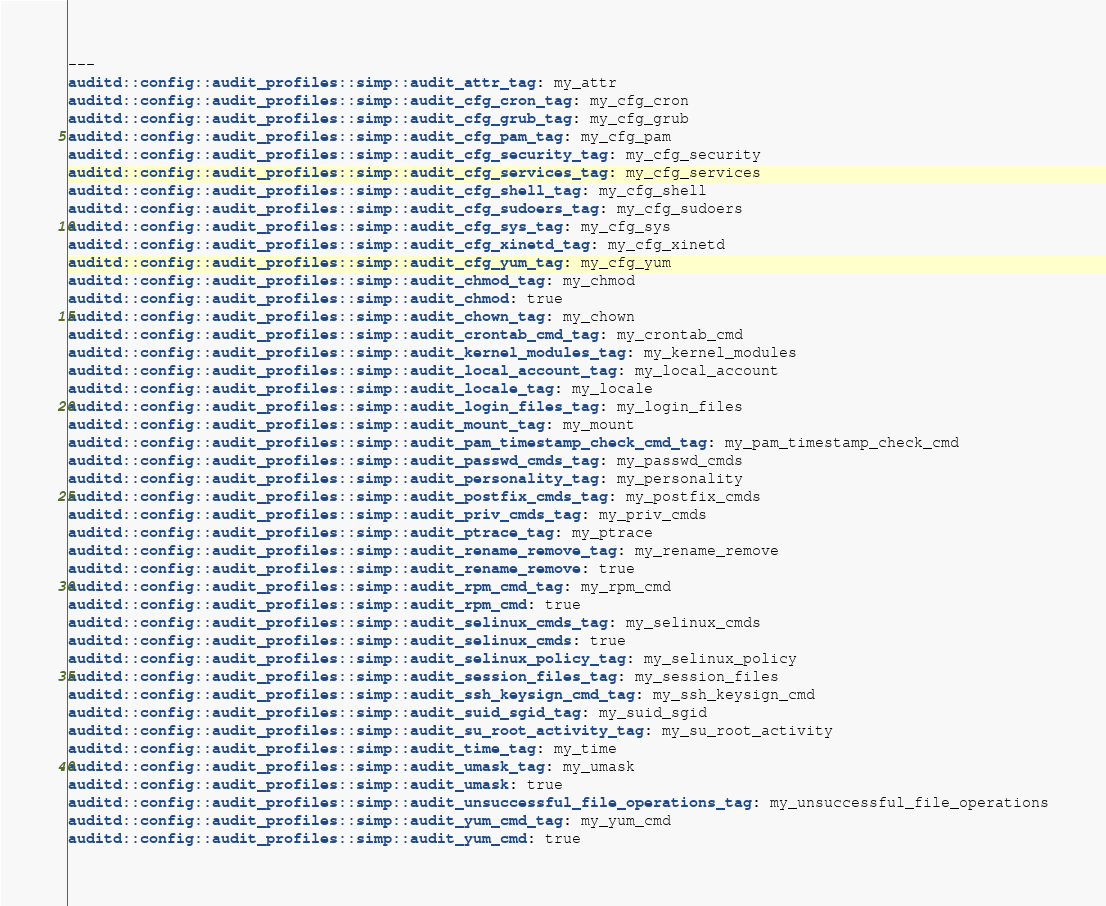Convert code to text. <code><loc_0><loc_0><loc_500><loc_500><_YAML_>---
auditd::config::audit_profiles::simp::audit_attr_tag: my_attr
auditd::config::audit_profiles::simp::audit_cfg_cron_tag: my_cfg_cron
auditd::config::audit_profiles::simp::audit_cfg_grub_tag: my_cfg_grub
auditd::config::audit_profiles::simp::audit_cfg_pam_tag: my_cfg_pam
auditd::config::audit_profiles::simp::audit_cfg_security_tag: my_cfg_security
auditd::config::audit_profiles::simp::audit_cfg_services_tag: my_cfg_services
auditd::config::audit_profiles::simp::audit_cfg_shell_tag: my_cfg_shell
auditd::config::audit_profiles::simp::audit_cfg_sudoers_tag: my_cfg_sudoers
auditd::config::audit_profiles::simp::audit_cfg_sys_tag: my_cfg_sys
auditd::config::audit_profiles::simp::audit_cfg_xinetd_tag: my_cfg_xinetd
auditd::config::audit_profiles::simp::audit_cfg_yum_tag: my_cfg_yum
auditd::config::audit_profiles::simp::audit_chmod_tag: my_chmod
auditd::config::audit_profiles::simp::audit_chmod: true
auditd::config::audit_profiles::simp::audit_chown_tag: my_chown
auditd::config::audit_profiles::simp::audit_crontab_cmd_tag: my_crontab_cmd
auditd::config::audit_profiles::simp::audit_kernel_modules_tag: my_kernel_modules
auditd::config::audit_profiles::simp::audit_local_account_tag: my_local_account
auditd::config::audit_profiles::simp::audit_locale_tag: my_locale
auditd::config::audit_profiles::simp::audit_login_files_tag: my_login_files
auditd::config::audit_profiles::simp::audit_mount_tag: my_mount
auditd::config::audit_profiles::simp::audit_pam_timestamp_check_cmd_tag: my_pam_timestamp_check_cmd
auditd::config::audit_profiles::simp::audit_passwd_cmds_tag: my_passwd_cmds
auditd::config::audit_profiles::simp::audit_personality_tag: my_personality
auditd::config::audit_profiles::simp::audit_postfix_cmds_tag: my_postfix_cmds
auditd::config::audit_profiles::simp::audit_priv_cmds_tag: my_priv_cmds
auditd::config::audit_profiles::simp::audit_ptrace_tag: my_ptrace
auditd::config::audit_profiles::simp::audit_rename_remove_tag: my_rename_remove
auditd::config::audit_profiles::simp::audit_rename_remove: true
auditd::config::audit_profiles::simp::audit_rpm_cmd_tag: my_rpm_cmd
auditd::config::audit_profiles::simp::audit_rpm_cmd: true
auditd::config::audit_profiles::simp::audit_selinux_cmds_tag: my_selinux_cmds
auditd::config::audit_profiles::simp::audit_selinux_cmds: true
auditd::config::audit_profiles::simp::audit_selinux_policy_tag: my_selinux_policy
auditd::config::audit_profiles::simp::audit_session_files_tag: my_session_files
auditd::config::audit_profiles::simp::audit_ssh_keysign_cmd_tag: my_ssh_keysign_cmd
auditd::config::audit_profiles::simp::audit_suid_sgid_tag: my_suid_sgid
auditd::config::audit_profiles::simp::audit_su_root_activity_tag: my_su_root_activity
auditd::config::audit_profiles::simp::audit_time_tag: my_time
auditd::config::audit_profiles::simp::audit_umask_tag: my_umask
auditd::config::audit_profiles::simp::audit_umask: true
auditd::config::audit_profiles::simp::audit_unsuccessful_file_operations_tag: my_unsuccessful_file_operations
auditd::config::audit_profiles::simp::audit_yum_cmd_tag: my_yum_cmd
auditd::config::audit_profiles::simp::audit_yum_cmd: true
</code> 